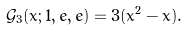<formula> <loc_0><loc_0><loc_500><loc_500>\mathcal { G } _ { 3 } ( x ; 1 , e , e ) = 3 ( x ^ { 2 } - x ) .</formula> 